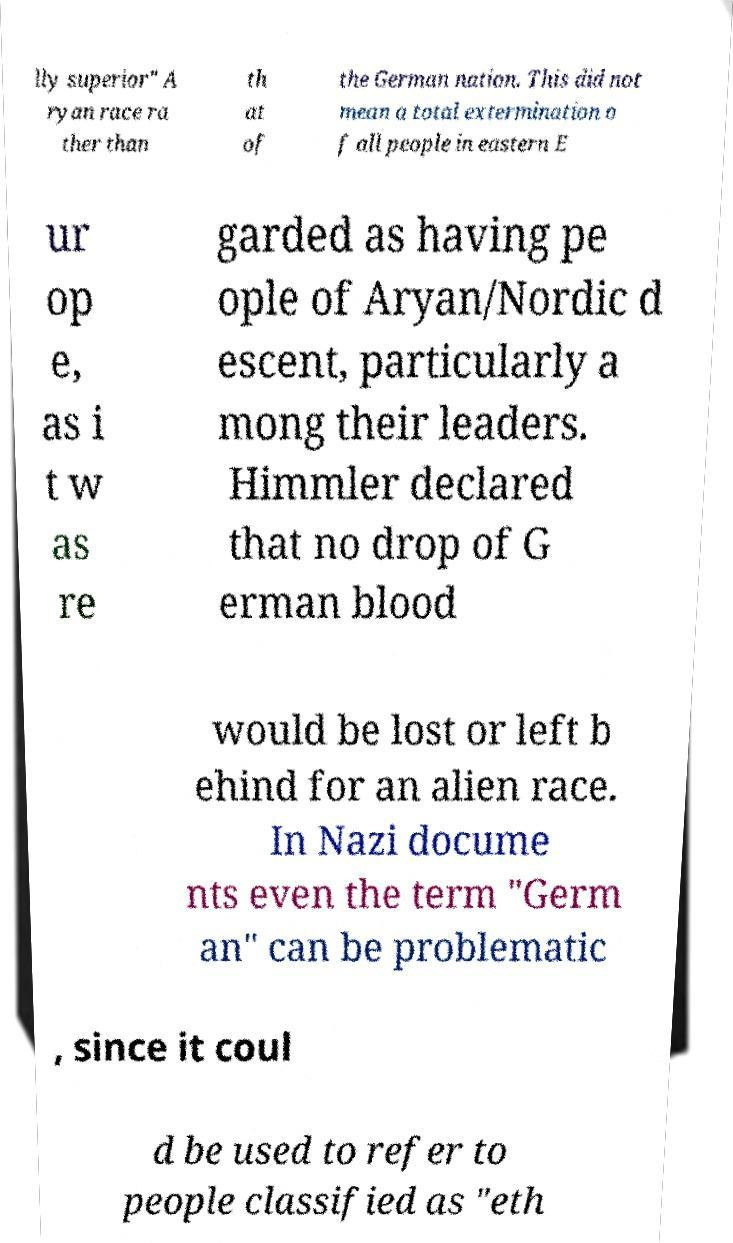What messages or text are displayed in this image? I need them in a readable, typed format. lly superior" A ryan race ra ther than th at of the German nation. This did not mean a total extermination o f all people in eastern E ur op e, as i t w as re garded as having pe ople of Aryan/Nordic d escent, particularly a mong their leaders. Himmler declared that no drop of G erman blood would be lost or left b ehind for an alien race. In Nazi docume nts even the term "Germ an" can be problematic , since it coul d be used to refer to people classified as "eth 